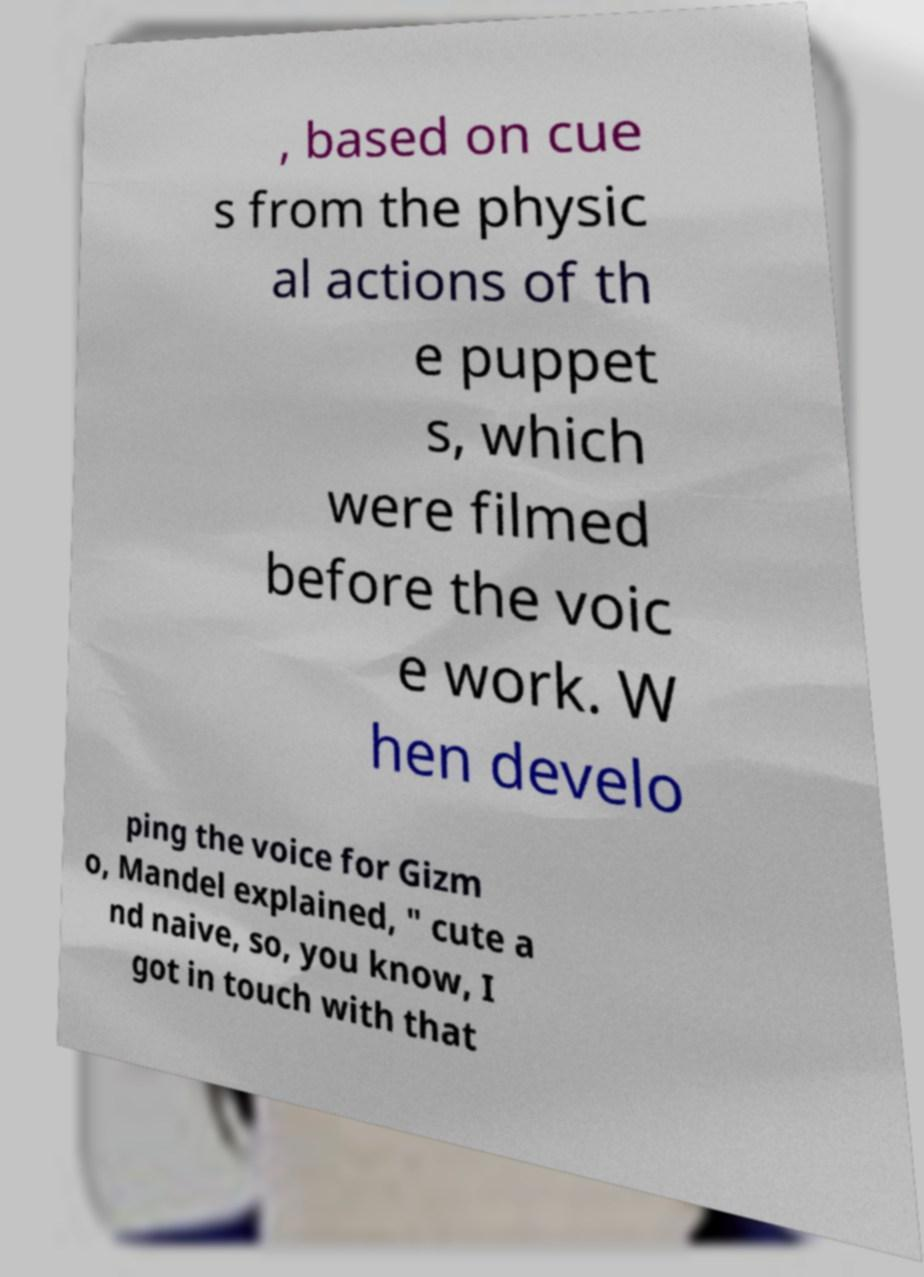Please read and relay the text visible in this image. What does it say? , based on cue s from the physic al actions of th e puppet s, which were filmed before the voic e work. W hen develo ping the voice for Gizm o, Mandel explained, " cute a nd naive, so, you know, I got in touch with that 